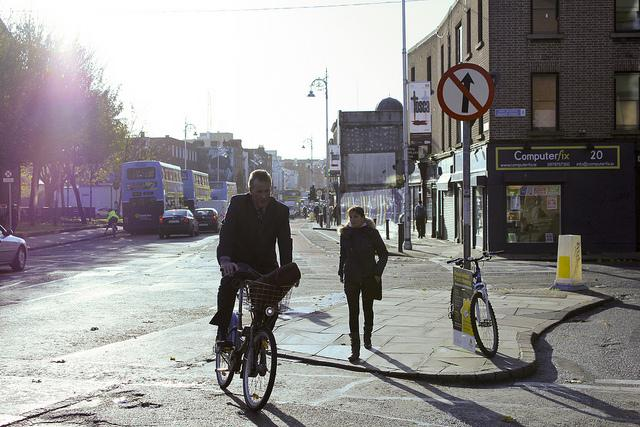Where is the man on the bicycle possibly going? work 